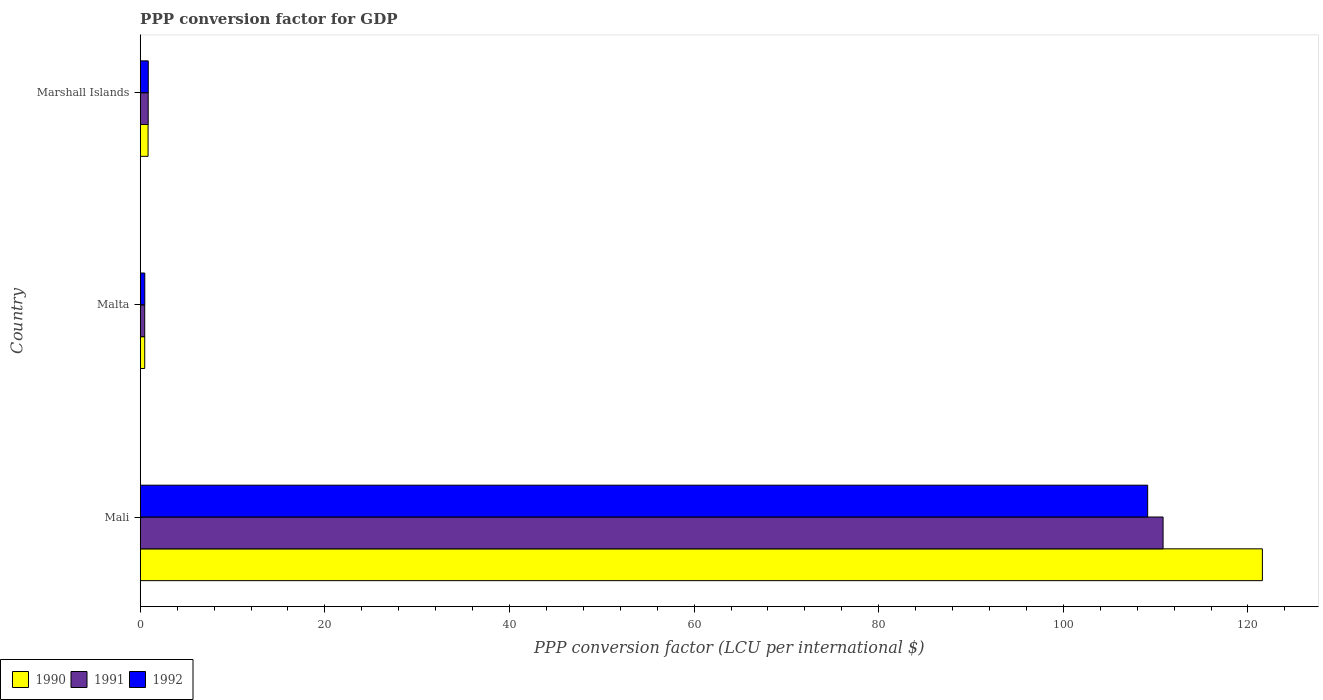How many different coloured bars are there?
Offer a terse response. 3. How many groups of bars are there?
Keep it short and to the point. 3. Are the number of bars per tick equal to the number of legend labels?
Your answer should be very brief. Yes. How many bars are there on the 3rd tick from the top?
Offer a terse response. 3. How many bars are there on the 3rd tick from the bottom?
Your answer should be compact. 3. What is the label of the 2nd group of bars from the top?
Give a very brief answer. Malta. What is the PPP conversion factor for GDP in 1991 in Malta?
Your answer should be compact. 0.49. Across all countries, what is the maximum PPP conversion factor for GDP in 1992?
Offer a terse response. 109.13. Across all countries, what is the minimum PPP conversion factor for GDP in 1992?
Offer a very short reply. 0.49. In which country was the PPP conversion factor for GDP in 1991 maximum?
Provide a short and direct response. Mali. In which country was the PPP conversion factor for GDP in 1990 minimum?
Keep it short and to the point. Malta. What is the total PPP conversion factor for GDP in 1991 in the graph?
Offer a terse response. 112.15. What is the difference between the PPP conversion factor for GDP in 1992 in Mali and that in Marshall Islands?
Offer a terse response. 108.26. What is the difference between the PPP conversion factor for GDP in 1990 in Malta and the PPP conversion factor for GDP in 1992 in Mali?
Your answer should be very brief. -108.65. What is the average PPP conversion factor for GDP in 1992 per country?
Give a very brief answer. 36.83. What is the difference between the PPP conversion factor for GDP in 1990 and PPP conversion factor for GDP in 1991 in Marshall Islands?
Provide a succinct answer. -0.01. In how many countries, is the PPP conversion factor for GDP in 1991 greater than 84 LCU?
Provide a short and direct response. 1. What is the ratio of the PPP conversion factor for GDP in 1991 in Mali to that in Malta?
Ensure brevity in your answer.  227.61. Is the PPP conversion factor for GDP in 1991 in Mali less than that in Marshall Islands?
Offer a terse response. No. Is the difference between the PPP conversion factor for GDP in 1990 in Mali and Marshall Islands greater than the difference between the PPP conversion factor for GDP in 1991 in Mali and Marshall Islands?
Keep it short and to the point. Yes. What is the difference between the highest and the second highest PPP conversion factor for GDP in 1990?
Your response must be concise. 120.71. What is the difference between the highest and the lowest PPP conversion factor for GDP in 1992?
Ensure brevity in your answer.  108.64. Is the sum of the PPP conversion factor for GDP in 1991 in Mali and Malta greater than the maximum PPP conversion factor for GDP in 1990 across all countries?
Your response must be concise. No. What does the 3rd bar from the bottom in Mali represents?
Your answer should be compact. 1992. How many bars are there?
Provide a succinct answer. 9. Are the values on the major ticks of X-axis written in scientific E-notation?
Your answer should be very brief. No. Does the graph contain any zero values?
Your answer should be compact. No. Does the graph contain grids?
Make the answer very short. No. How are the legend labels stacked?
Ensure brevity in your answer.  Horizontal. What is the title of the graph?
Your answer should be compact. PPP conversion factor for GDP. Does "1986" appear as one of the legend labels in the graph?
Give a very brief answer. No. What is the label or title of the X-axis?
Make the answer very short. PPP conversion factor (LCU per international $). What is the label or title of the Y-axis?
Ensure brevity in your answer.  Country. What is the PPP conversion factor (LCU per international $) in 1990 in Mali?
Your response must be concise. 121.56. What is the PPP conversion factor (LCU per international $) in 1991 in Mali?
Provide a short and direct response. 110.8. What is the PPP conversion factor (LCU per international $) of 1992 in Mali?
Your answer should be compact. 109.13. What is the PPP conversion factor (LCU per international $) of 1990 in Malta?
Make the answer very short. 0.49. What is the PPP conversion factor (LCU per international $) in 1991 in Malta?
Ensure brevity in your answer.  0.49. What is the PPP conversion factor (LCU per international $) of 1992 in Malta?
Ensure brevity in your answer.  0.49. What is the PPP conversion factor (LCU per international $) of 1990 in Marshall Islands?
Your answer should be compact. 0.85. What is the PPP conversion factor (LCU per international $) in 1991 in Marshall Islands?
Provide a short and direct response. 0.86. What is the PPP conversion factor (LCU per international $) of 1992 in Marshall Islands?
Your response must be concise. 0.87. Across all countries, what is the maximum PPP conversion factor (LCU per international $) of 1990?
Keep it short and to the point. 121.56. Across all countries, what is the maximum PPP conversion factor (LCU per international $) in 1991?
Provide a succinct answer. 110.8. Across all countries, what is the maximum PPP conversion factor (LCU per international $) of 1992?
Make the answer very short. 109.13. Across all countries, what is the minimum PPP conversion factor (LCU per international $) of 1990?
Provide a short and direct response. 0.49. Across all countries, what is the minimum PPP conversion factor (LCU per international $) in 1991?
Ensure brevity in your answer.  0.49. Across all countries, what is the minimum PPP conversion factor (LCU per international $) of 1992?
Provide a succinct answer. 0.49. What is the total PPP conversion factor (LCU per international $) in 1990 in the graph?
Provide a succinct answer. 122.9. What is the total PPP conversion factor (LCU per international $) of 1991 in the graph?
Offer a very short reply. 112.15. What is the total PPP conversion factor (LCU per international $) of 1992 in the graph?
Provide a succinct answer. 110.5. What is the difference between the PPP conversion factor (LCU per international $) in 1990 in Mali and that in Malta?
Give a very brief answer. 121.08. What is the difference between the PPP conversion factor (LCU per international $) in 1991 in Mali and that in Malta?
Your answer should be very brief. 110.32. What is the difference between the PPP conversion factor (LCU per international $) of 1992 in Mali and that in Malta?
Provide a succinct answer. 108.64. What is the difference between the PPP conversion factor (LCU per international $) of 1990 in Mali and that in Marshall Islands?
Your response must be concise. 120.71. What is the difference between the PPP conversion factor (LCU per international $) of 1991 in Mali and that in Marshall Islands?
Your answer should be compact. 109.94. What is the difference between the PPP conversion factor (LCU per international $) of 1992 in Mali and that in Marshall Islands?
Offer a very short reply. 108.26. What is the difference between the PPP conversion factor (LCU per international $) in 1990 in Malta and that in Marshall Islands?
Offer a terse response. -0.36. What is the difference between the PPP conversion factor (LCU per international $) in 1991 in Malta and that in Marshall Islands?
Offer a terse response. -0.38. What is the difference between the PPP conversion factor (LCU per international $) of 1992 in Malta and that in Marshall Islands?
Offer a very short reply. -0.38. What is the difference between the PPP conversion factor (LCU per international $) of 1990 in Mali and the PPP conversion factor (LCU per international $) of 1991 in Malta?
Your answer should be very brief. 121.08. What is the difference between the PPP conversion factor (LCU per international $) of 1990 in Mali and the PPP conversion factor (LCU per international $) of 1992 in Malta?
Ensure brevity in your answer.  121.07. What is the difference between the PPP conversion factor (LCU per international $) of 1991 in Mali and the PPP conversion factor (LCU per international $) of 1992 in Malta?
Keep it short and to the point. 110.31. What is the difference between the PPP conversion factor (LCU per international $) of 1990 in Mali and the PPP conversion factor (LCU per international $) of 1991 in Marshall Islands?
Offer a terse response. 120.7. What is the difference between the PPP conversion factor (LCU per international $) in 1990 in Mali and the PPP conversion factor (LCU per international $) in 1992 in Marshall Islands?
Your answer should be compact. 120.69. What is the difference between the PPP conversion factor (LCU per international $) in 1991 in Mali and the PPP conversion factor (LCU per international $) in 1992 in Marshall Islands?
Offer a very short reply. 109.93. What is the difference between the PPP conversion factor (LCU per international $) in 1990 in Malta and the PPP conversion factor (LCU per international $) in 1991 in Marshall Islands?
Provide a succinct answer. -0.38. What is the difference between the PPP conversion factor (LCU per international $) in 1990 in Malta and the PPP conversion factor (LCU per international $) in 1992 in Marshall Islands?
Provide a short and direct response. -0.38. What is the difference between the PPP conversion factor (LCU per international $) of 1991 in Malta and the PPP conversion factor (LCU per international $) of 1992 in Marshall Islands?
Your answer should be compact. -0.38. What is the average PPP conversion factor (LCU per international $) of 1990 per country?
Your answer should be compact. 40.97. What is the average PPP conversion factor (LCU per international $) of 1991 per country?
Ensure brevity in your answer.  37.38. What is the average PPP conversion factor (LCU per international $) of 1992 per country?
Provide a short and direct response. 36.83. What is the difference between the PPP conversion factor (LCU per international $) of 1990 and PPP conversion factor (LCU per international $) of 1991 in Mali?
Keep it short and to the point. 10.76. What is the difference between the PPP conversion factor (LCU per international $) in 1990 and PPP conversion factor (LCU per international $) in 1992 in Mali?
Ensure brevity in your answer.  12.43. What is the difference between the PPP conversion factor (LCU per international $) of 1991 and PPP conversion factor (LCU per international $) of 1992 in Mali?
Give a very brief answer. 1.67. What is the difference between the PPP conversion factor (LCU per international $) in 1990 and PPP conversion factor (LCU per international $) in 1991 in Malta?
Offer a terse response. -0. What is the difference between the PPP conversion factor (LCU per international $) of 1990 and PPP conversion factor (LCU per international $) of 1992 in Malta?
Make the answer very short. -0.01. What is the difference between the PPP conversion factor (LCU per international $) of 1991 and PPP conversion factor (LCU per international $) of 1992 in Malta?
Make the answer very short. -0.01. What is the difference between the PPP conversion factor (LCU per international $) of 1990 and PPP conversion factor (LCU per international $) of 1991 in Marshall Islands?
Provide a succinct answer. -0.01. What is the difference between the PPP conversion factor (LCU per international $) of 1990 and PPP conversion factor (LCU per international $) of 1992 in Marshall Islands?
Ensure brevity in your answer.  -0.02. What is the difference between the PPP conversion factor (LCU per international $) of 1991 and PPP conversion factor (LCU per international $) of 1992 in Marshall Islands?
Make the answer very short. -0.01. What is the ratio of the PPP conversion factor (LCU per international $) of 1990 in Mali to that in Malta?
Keep it short and to the point. 249.76. What is the ratio of the PPP conversion factor (LCU per international $) in 1991 in Mali to that in Malta?
Provide a succinct answer. 227.61. What is the ratio of the PPP conversion factor (LCU per international $) in 1992 in Mali to that in Malta?
Keep it short and to the point. 221.42. What is the ratio of the PPP conversion factor (LCU per international $) in 1990 in Mali to that in Marshall Islands?
Make the answer very short. 143.05. What is the ratio of the PPP conversion factor (LCU per international $) in 1991 in Mali to that in Marshall Islands?
Give a very brief answer. 128.26. What is the ratio of the PPP conversion factor (LCU per international $) in 1992 in Mali to that in Marshall Islands?
Your answer should be compact. 125.42. What is the ratio of the PPP conversion factor (LCU per international $) in 1990 in Malta to that in Marshall Islands?
Offer a terse response. 0.57. What is the ratio of the PPP conversion factor (LCU per international $) in 1991 in Malta to that in Marshall Islands?
Offer a very short reply. 0.56. What is the ratio of the PPP conversion factor (LCU per international $) of 1992 in Malta to that in Marshall Islands?
Give a very brief answer. 0.57. What is the difference between the highest and the second highest PPP conversion factor (LCU per international $) of 1990?
Offer a very short reply. 120.71. What is the difference between the highest and the second highest PPP conversion factor (LCU per international $) of 1991?
Your answer should be compact. 109.94. What is the difference between the highest and the second highest PPP conversion factor (LCU per international $) in 1992?
Offer a very short reply. 108.26. What is the difference between the highest and the lowest PPP conversion factor (LCU per international $) of 1990?
Your answer should be compact. 121.08. What is the difference between the highest and the lowest PPP conversion factor (LCU per international $) of 1991?
Give a very brief answer. 110.32. What is the difference between the highest and the lowest PPP conversion factor (LCU per international $) in 1992?
Give a very brief answer. 108.64. 